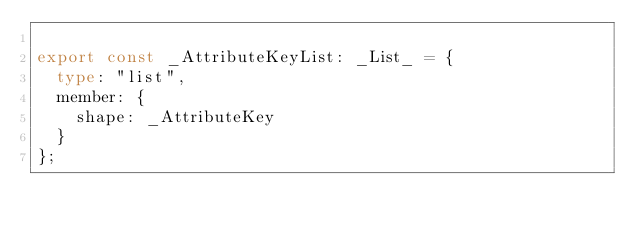Convert code to text. <code><loc_0><loc_0><loc_500><loc_500><_TypeScript_>
export const _AttributeKeyList: _List_ = {
  type: "list",
  member: {
    shape: _AttributeKey
  }
};
</code> 